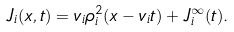Convert formula to latex. <formula><loc_0><loc_0><loc_500><loc_500>J _ { i } ( x , t ) = v _ { i } \rho _ { i } ^ { 2 } ( x - v _ { i } t ) + J _ { i } ^ { \infty } ( t ) .</formula> 